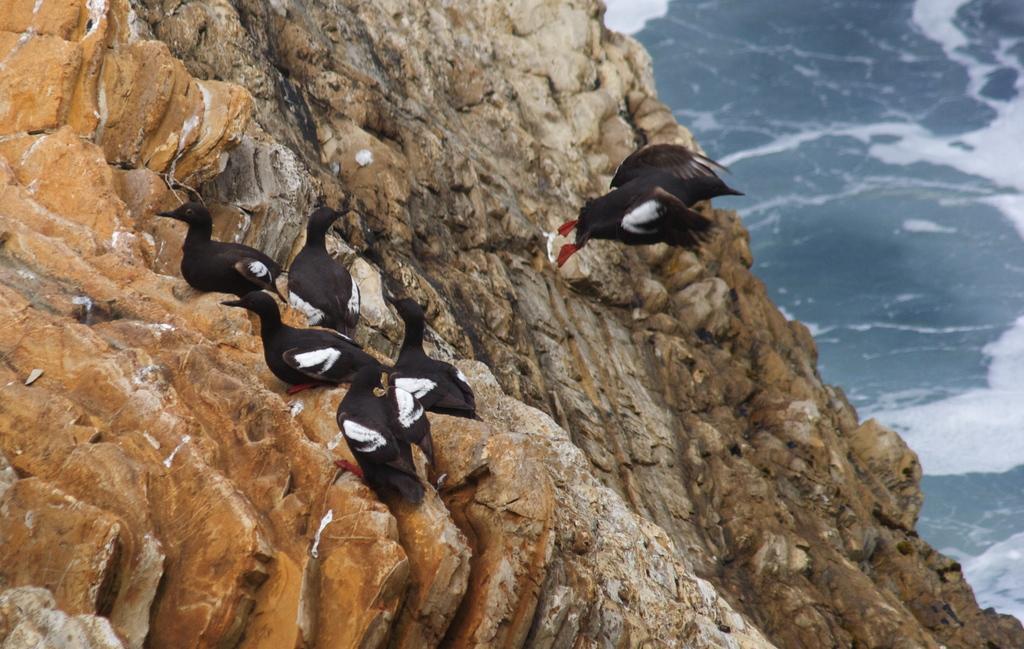Could you give a brief overview of what you see in this image? In this image I can see few birds and I can see colour of these birds are black and white. 